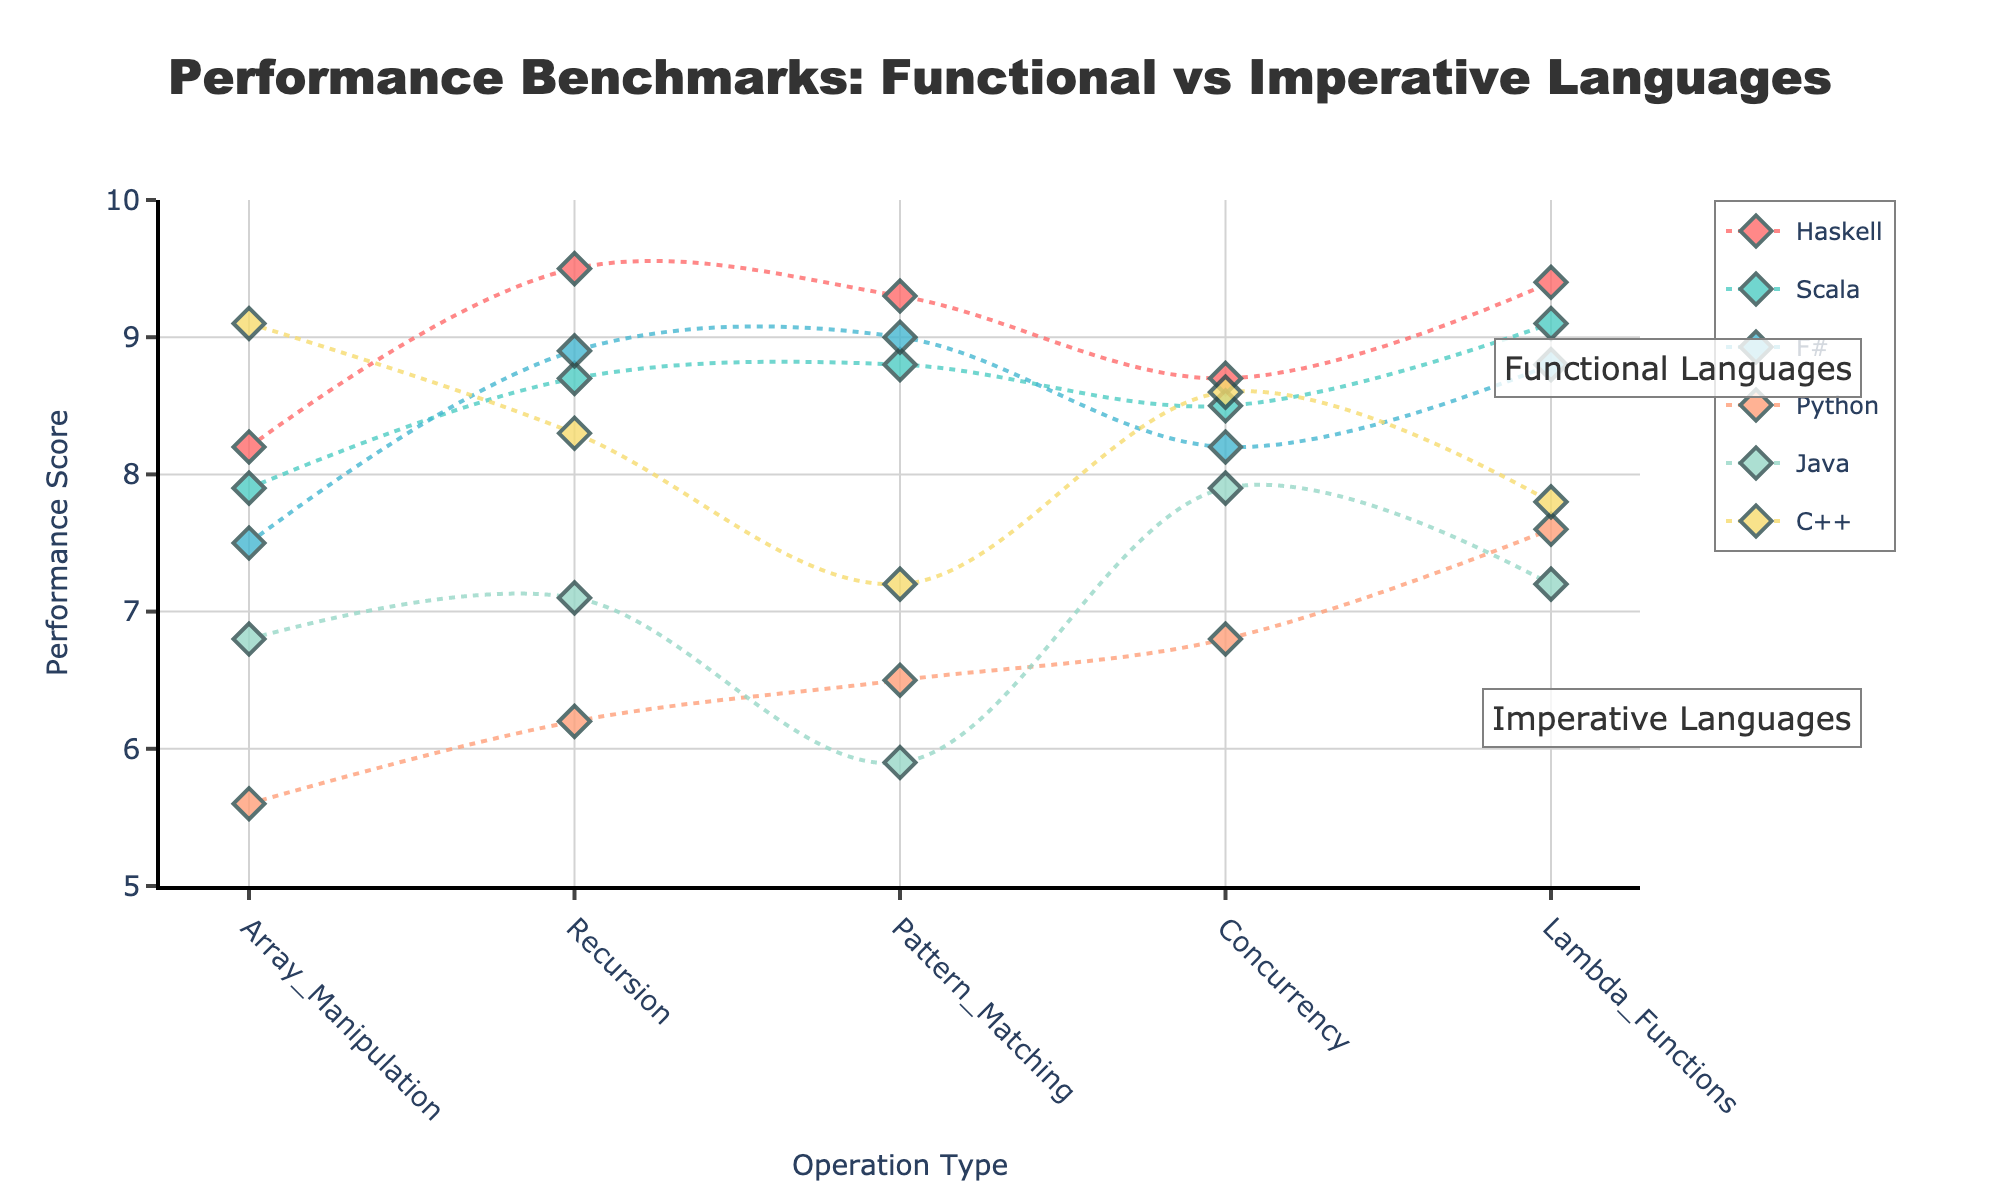Which language has the highest performance score for recursion? Haskell has the highest performance score for recursion. This can be seen by looking at the data points related to recursion and observing that Haskell has the highest value.
Answer: Haskell What is the average performance score for Scala across all operations? To find the average performance score for Scala, sum all of Scala's performance scores (7.9 + 8.7 + 8.8 + 8.5 + 9.1) and then divide by the number of operations (5). The total is 43, and the average is 43/5.
Answer: 8.6 Which operation shows the greatest performance difference between Haskell and Python? Calculate the difference between Haskell and Python performance scores for each operation: Array Manipulation (8.2 - 5.6 = 2.6), Recursion (9.5 - 6.2 = 3.3), Pattern Matching (9.3 - 6.5 = 2.8), Concurrency (8.7 - 6.8 = 1.9), Lambda Functions (9.4 - 7.6 = 1.8). Recursion has the greatest difference.
Answer: Recursion Which imperative language has the best average performance score across all operations? Compute the average performance score for each imperative language: Python (average of 5.6, 6.2, 6.5, 6.8, 7.6 = 6.54), Java (average of 6.8, 7.1, 5.9, 7.9, 7.2 = 6.98), C++ (average of 9.1, 8.3, 7.2, 8.6, 7.8 = 8.2). C++ has the highest average.
Answer: C++ How does F#'s performance in Concurrency compare to its performance in Lambda Functions? Check the performance scores of F# for Concurrency (8.2) and Lambda Functions (8.8). F# performs better in Lambda Functions than in Concurrency by a difference of 0.6.
Answer: Lambda Functions Is Haskell consistently the top-performing functional language across all operations? Observe Haskell's performance scores across all operations and compare them with Scala and F#. For each operation: Array Manipulation (H: 8.2, S: 7.9, F: 7.5), Recursion (H: 9.5, S: 8.7, F: 8.9), Pattern Matching (H: 9.3, S: 8.8, F: 9.0), Concurrency (H: 8.7, S: 8.5, F: 8.2), Lambda Functions (H: 9.4, S: 9.1, F: 8.8). Haskell has the highest score among the functional languages in all operations.
Answer: Yes Which language has the lowest performance score for Pattern Matching? By checking the performance scores for Pattern Matching, the lowest score belongs to Java, with a value of 5.9.
Answer: Java 